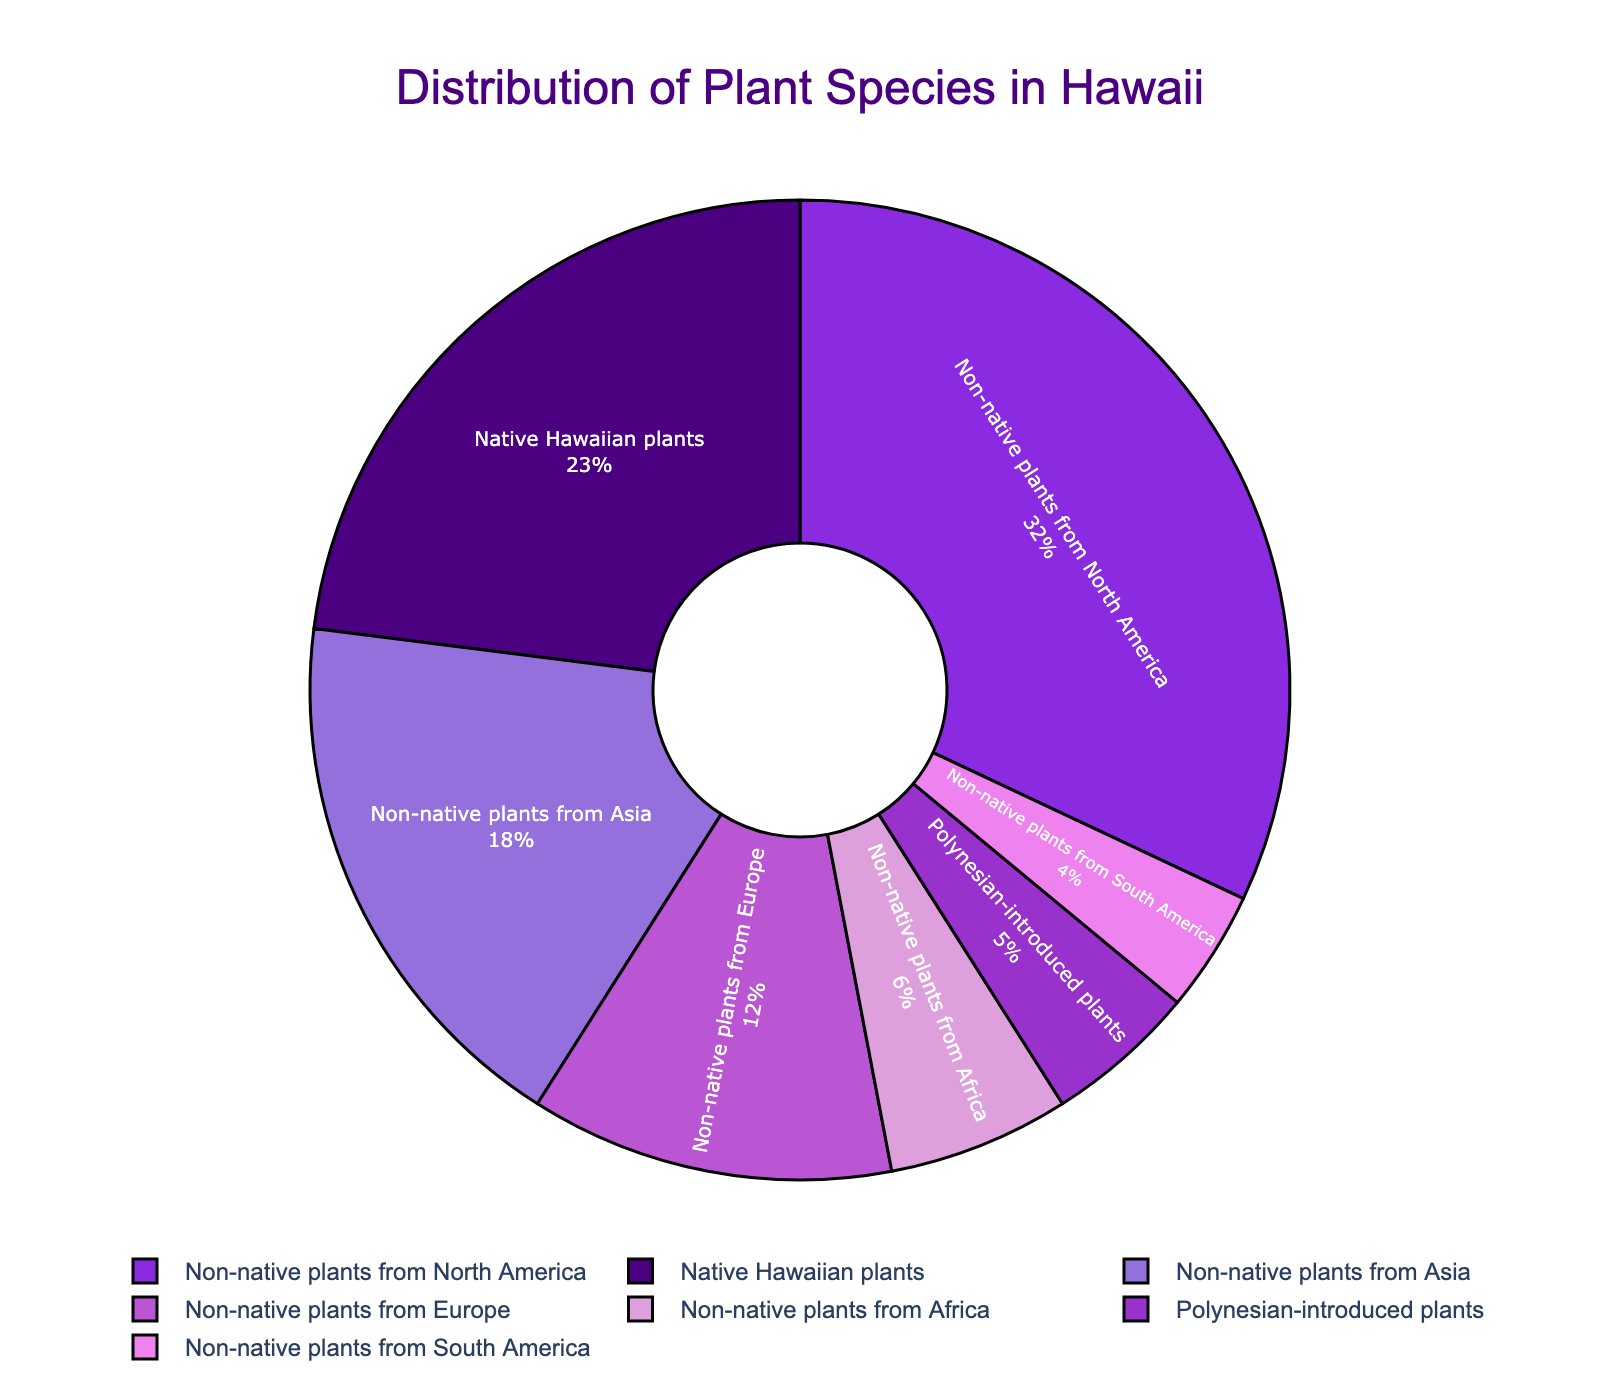What's the largest category of plant species in Hawaii according to the pie chart? By looking at the pie chart, the largest section corresponds to "Non-native plants from North America," which occupies the most significant area.
Answer: Non-native plants from North America What percentage of plant species are non-native compared to native Hawaiian plants? Sum the percentages of all non-native categories: Non-native plants from North America (32) + Non-native plants from Asia (18) + Non-native plants from Europe (12) + Non-native plants from Africa (6) + Non-native plants from South America (4) = 72%. The percentage of native Hawaiian plants is 23%.
Answer: 72% non-native, 23% native Which region contributes the least to the non-native plant species in Hawaii? The smallest section among the non-native categories is "Non-native plants from South America," which has the smallest percentage.
Answer: Non-native plants from South America What is the sum of the percentages of Polynesian-introduced plants and non-native plants from Asia? Polynesian-introduced plants are 5%, and non-native plants from Asia are 18%. Summing them up: 5 + 18 = 23%.
Answer: 23% Are there more non-native plants from Europe or from Asia? Comparing the percentages, non-native plants from Asia are 18%, and non-native plants from Europe are 12%. Hence, there are more non-native plants from Asia.
Answer: Non-native plants from Asia What is the difference in percentage between non-native plants from North America and non-native plants from Europe? The percentage of non-native plants from North America is 32%, and from Europe is 12%. The difference is 32 - 12 = 20%.
Answer: 20% How many categories have a percentage higher than Polynesian-introduced plants? Polynesian-introduced plants have a percentage of 5%. The categories with higher percentages are Native Hawaiian plants (23), Non-native plants from North America (32), Non-native plants from Asia (18), Non-native plants from Europe (12), and Non-native plants from Africa (6), making a total of 5 categories.
Answer: 5 What is the combined percentage of native Hawaiian plants and non-native plants from Africa? Native Hawaiian plants are 23%, and non-native plants from Africa are 6%. Summing them up: 23 + 6 = 29%.
Answer: 29% Which color represents the native Hawaiian plants in the pie chart? The section for "Native Hawaiian plants" is the one colored with a distinct color, and according to the custom color palette provided, it should be the first listed color (likely dark violet/indigo).
Answer: Dark violet/Indigo 